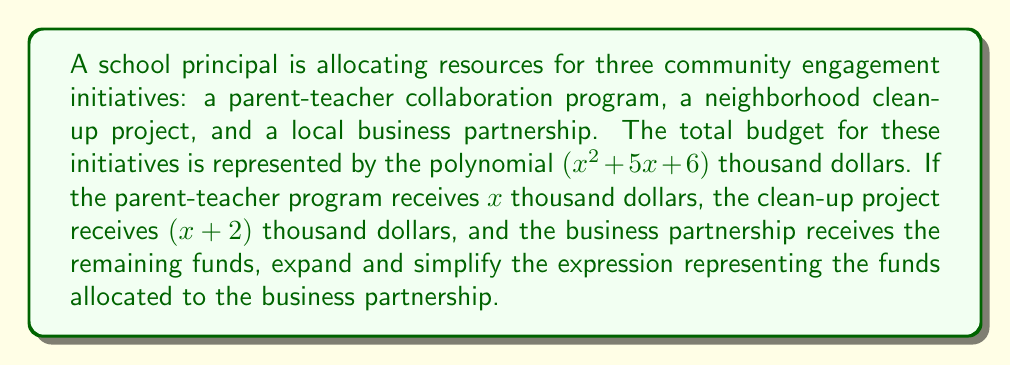Help me with this question. Let's approach this step-by-step:

1) The total budget is $$(x^2 + 5x + 6)$$ thousand dollars.

2) The parent-teacher program receives $$x$$ thousand dollars.

3) The clean-up project receives $$(x + 2)$$ thousand dollars.

4) To find the funds for the business partnership, we need to subtract the funds for the other two programs from the total budget:

   $$(x^2 + 5x + 6) - x - (x + 2)$$

5) Let's expand this:
   $$x^2 + 5x + 6 - x - x - 2$$

6) Simplify by combining like terms:
   $$x^2 + 3x + 4$$

Therefore, the funds allocated to the business partnership can be represented by the polynomial $$x^2 + 3x + 4$$ thousand dollars.
Answer: $$x^2 + 3x + 4$$ thousand dollars 